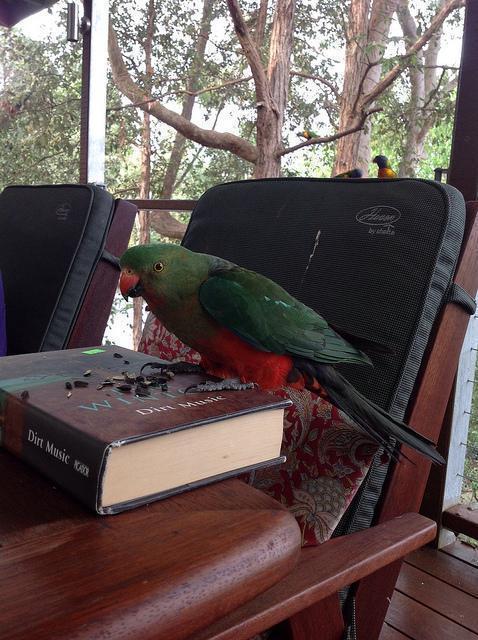What makes up the bulk of this bird's diet?
Indicate the correct response and explain using: 'Answer: answer
Rationale: rationale.'
Options: Vegetables, insects, seeds, fruits. Answer: fruits.
Rationale: The bird's diet is made of fruit. 